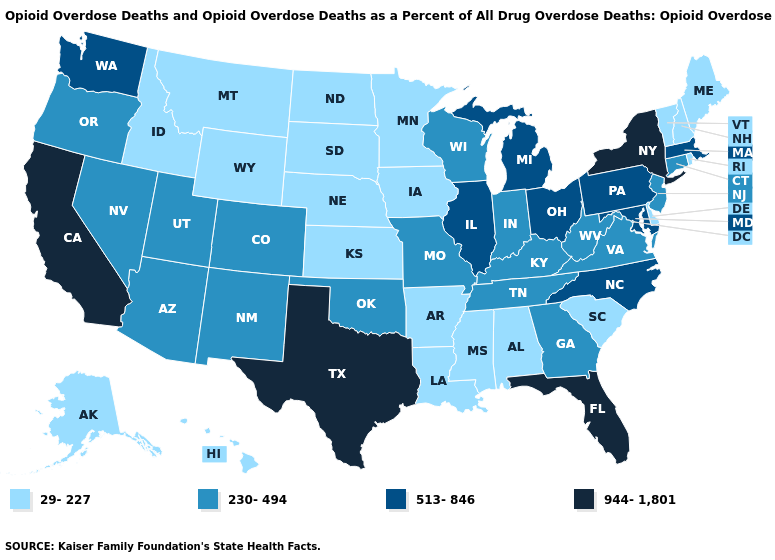What is the highest value in states that border Connecticut?
Write a very short answer. 944-1,801. Name the states that have a value in the range 230-494?
Be succinct. Arizona, Colorado, Connecticut, Georgia, Indiana, Kentucky, Missouri, Nevada, New Jersey, New Mexico, Oklahoma, Oregon, Tennessee, Utah, Virginia, West Virginia, Wisconsin. What is the lowest value in the MidWest?
Short answer required. 29-227. What is the value of Missouri?
Keep it brief. 230-494. Does the first symbol in the legend represent the smallest category?
Answer briefly. Yes. Does Nebraska have the lowest value in the MidWest?
Concise answer only. Yes. Which states have the lowest value in the South?
Short answer required. Alabama, Arkansas, Delaware, Louisiana, Mississippi, South Carolina. Which states have the highest value in the USA?
Keep it brief. California, Florida, New York, Texas. What is the value of Ohio?
Short answer required. 513-846. What is the value of Maryland?
Give a very brief answer. 513-846. How many symbols are there in the legend?
Write a very short answer. 4. Does the map have missing data?
Answer briefly. No. Among the states that border Montana , which have the highest value?
Concise answer only. Idaho, North Dakota, South Dakota, Wyoming. Name the states that have a value in the range 513-846?
Concise answer only. Illinois, Maryland, Massachusetts, Michigan, North Carolina, Ohio, Pennsylvania, Washington. What is the lowest value in the South?
Short answer required. 29-227. 